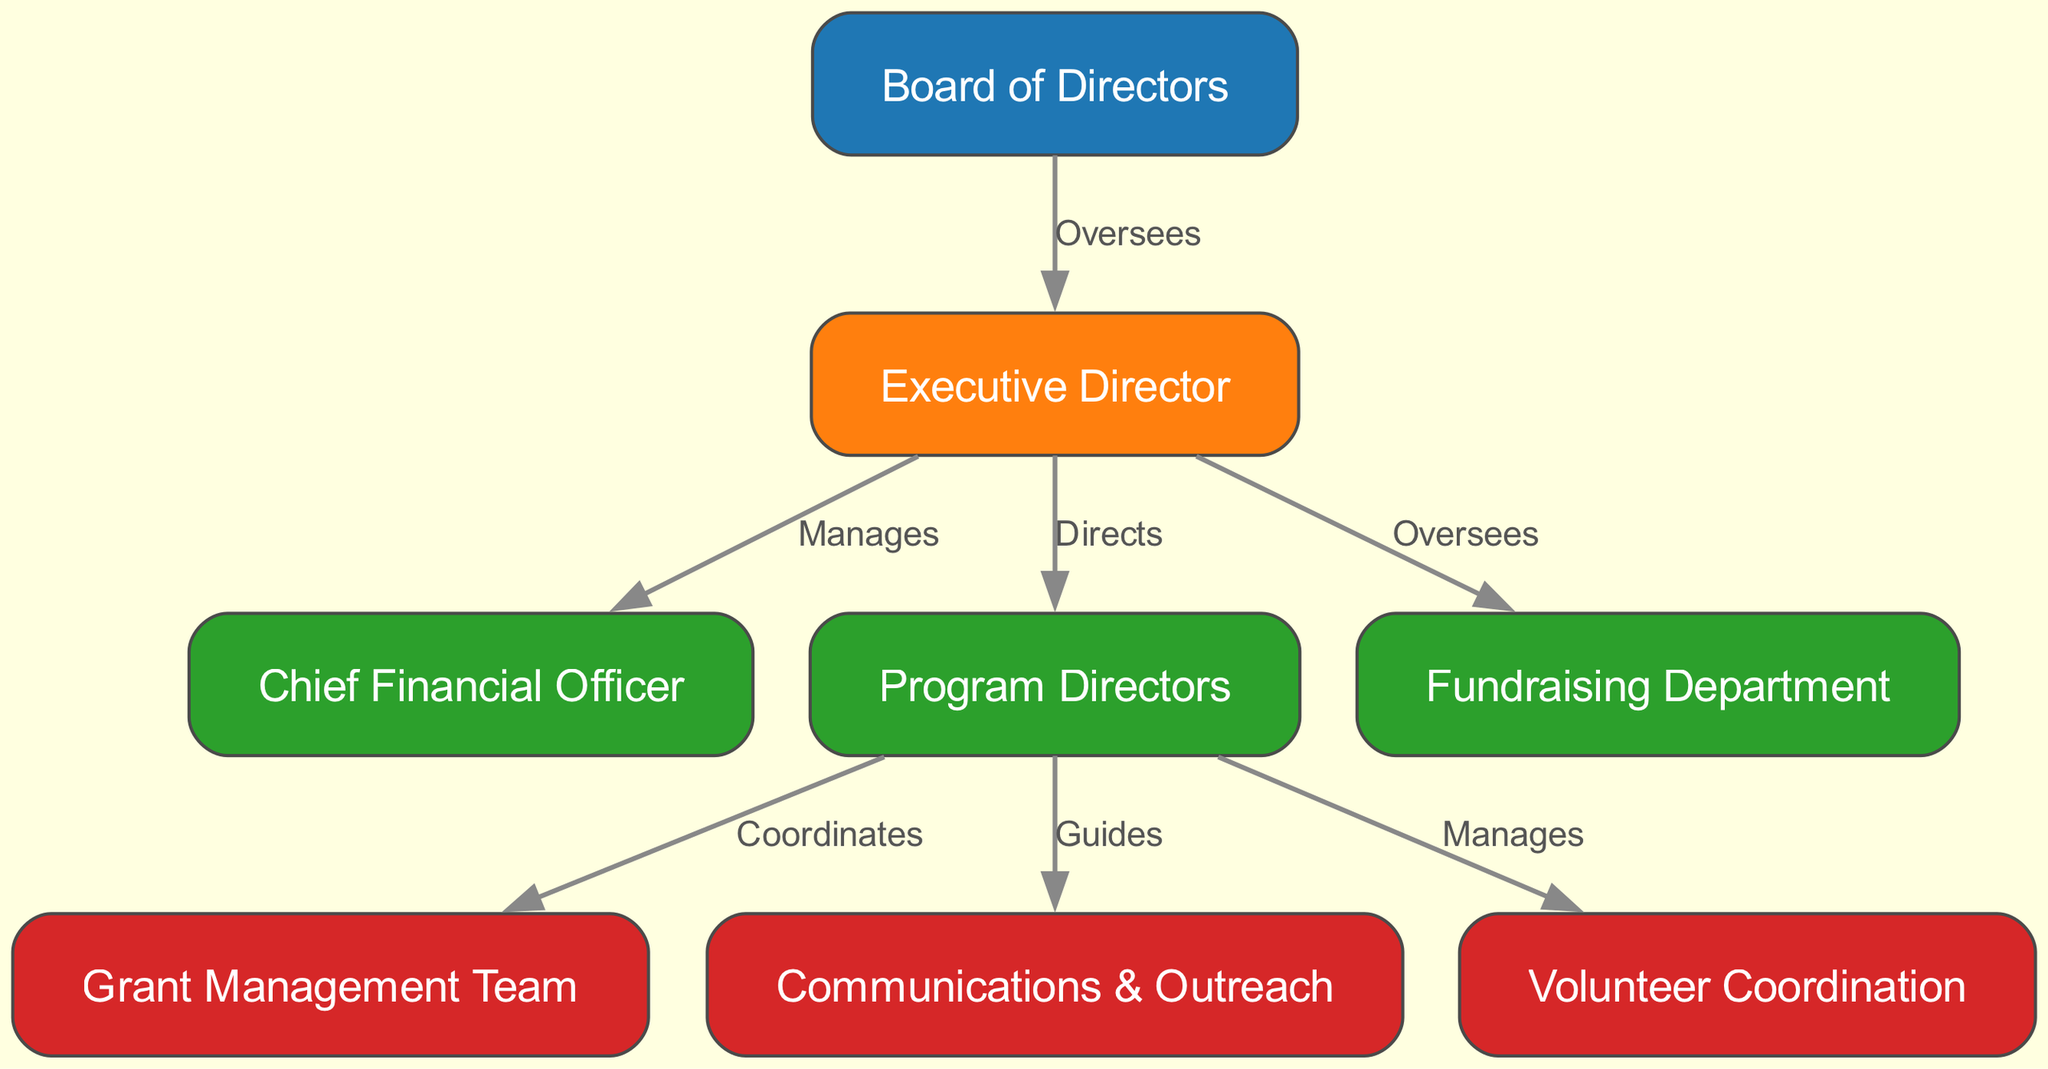What is the top node in the diagram? The diagram shows a hierarchical structure where the top node is the "Board of Directors". This is evident as it is the first node listed and has edges going downwards to the next level, symbolizing its oversight role.
Answer: Board of Directors How many nodes are there in total? Counting the nodes listed in the diagram, we see there are eight distinct nodes: Board of Directors, Executive Director, Chief Financial Officer, Program Directors, Fundraising Department, Grant Management Team, Communications & Outreach, and Volunteer Coordination.
Answer: Eight What role does the Executive Director have with the Program Directors? The edge connecting the Executive Director to the Program Directors is labeled "Directs", indicating that the Executive Director is responsible for providing direction to the Program Directors as part of the organizational structure.
Answer: Directs Which role manages the Grant Management Team? The diagram indicates that the "Program Directors" coordinate with the Grant Management Team. This is shown by the edge labeled "Coordinates" that connects the Program Directors to the Grant Management Team.
Answer: Program Directors What is the relationship between the Board of Directors and the Fundraising Department? The edge from the Board of Directors to the Fundraising Department is labeled "Oversees", suggesting that the Board of Directors has an overseeing role over the activities of the Fundraising Department within the organization.
Answer: Oversees Which department is responsible for volunteer coordination? The "Volunteer Coordination" node is directly connected to the "Program Directors" by the edge labeled "Manages", indicating that the Program Directors are responsible for coordinating the volunteers associated with the foundation.
Answer: Program Directors How many edges are present in the diagram? By counting the edges illustrated in the diagram, we find there are seven distinct connections between the roles indicating various relationships.
Answer: Seven Who does the Chief Financial Officer report to? The edge from the Executive Director to the Chief Financial Officer is labeled "Manages", which indicates that the Chief Financial Officer is managed by the Executive Director.
Answer: Executive Director 